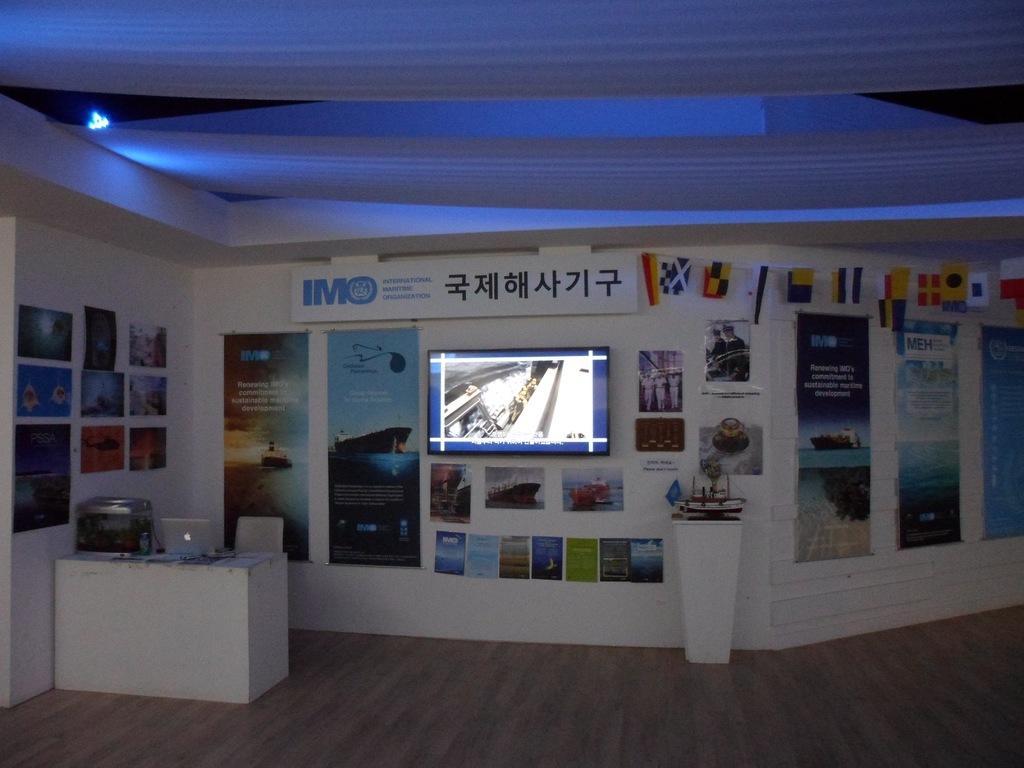How would you summarize this image in a sentence or two? On the left side, we see a table on which laptop, papers and some objects are placed. Beside that, we see a chair. In the background, we see a white wall on which television and many posters are pasted. In the middle of the picture, we see a table on which some objects are placed. At the top, we see the ceiling of the room. At the bottom, we see the wooden floor. 